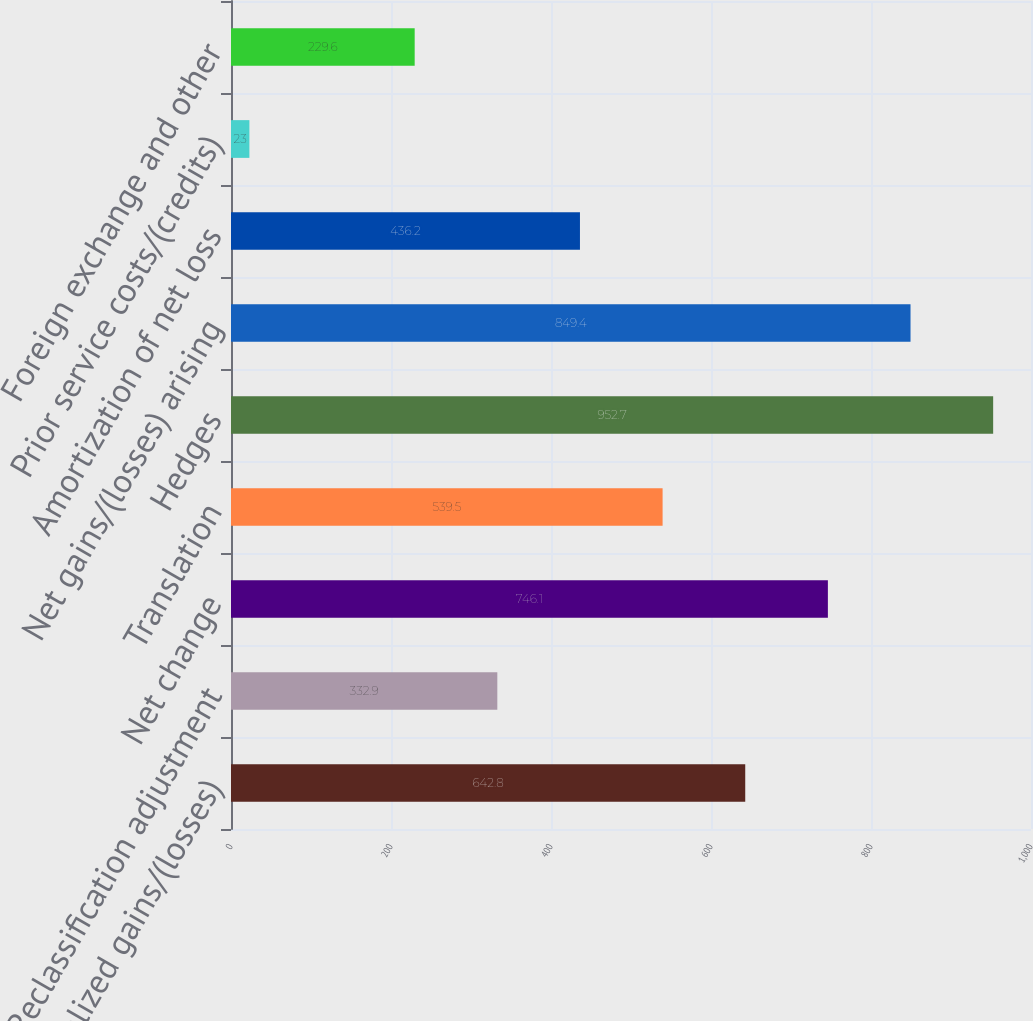Convert chart to OTSL. <chart><loc_0><loc_0><loc_500><loc_500><bar_chart><fcel>Net unrealized gains/(losses)<fcel>Reclassification adjustment<fcel>Net change<fcel>Translation<fcel>Hedges<fcel>Net gains/(losses) arising<fcel>Amortization of net loss<fcel>Prior service costs/(credits)<fcel>Foreign exchange and other<nl><fcel>642.8<fcel>332.9<fcel>746.1<fcel>539.5<fcel>952.7<fcel>849.4<fcel>436.2<fcel>23<fcel>229.6<nl></chart> 